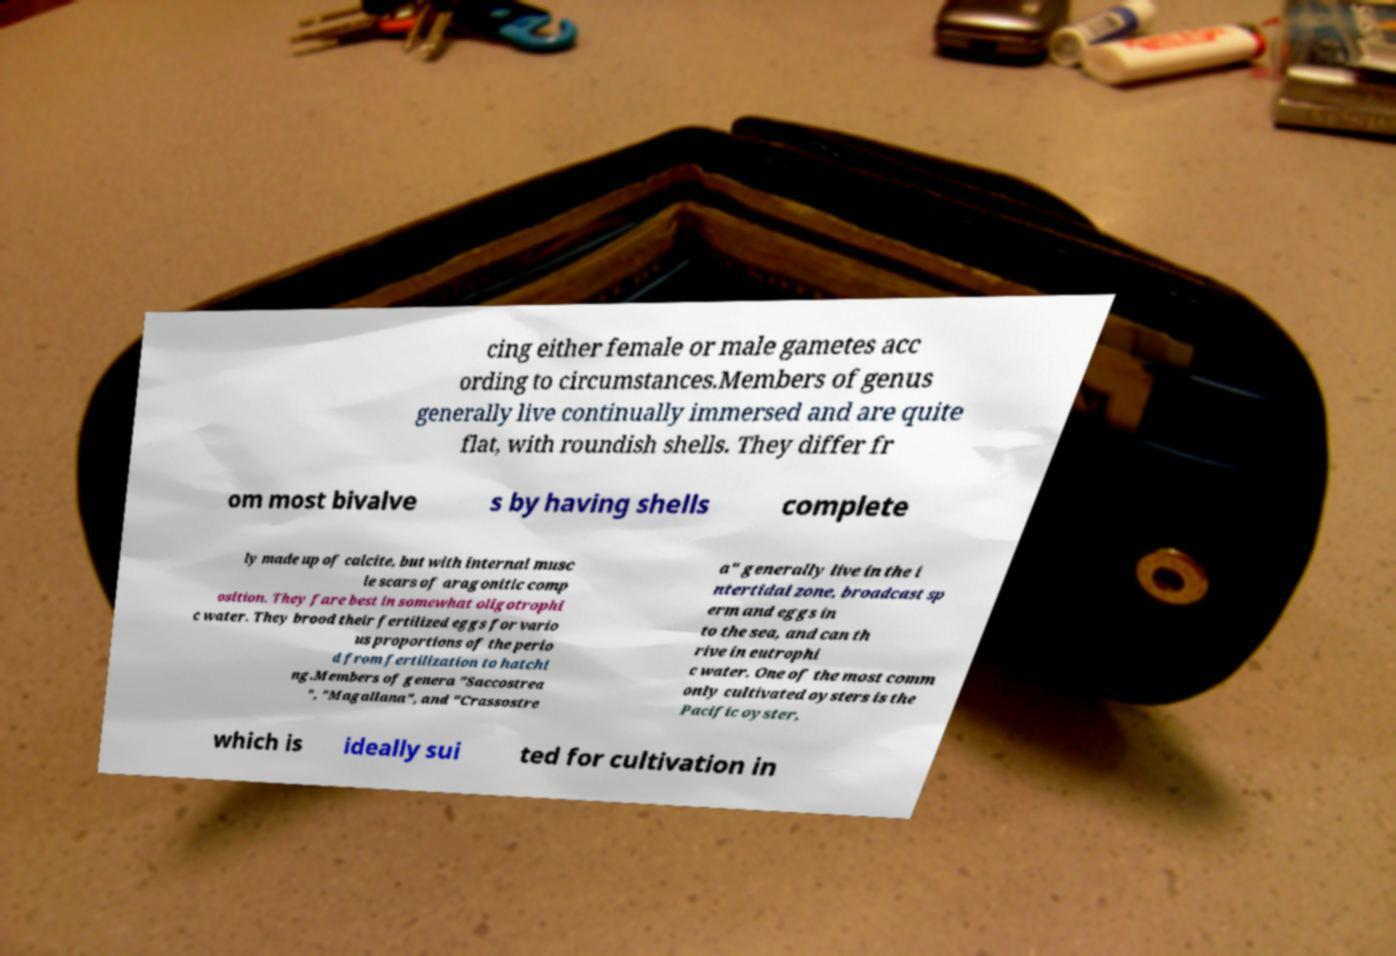Can you accurately transcribe the text from the provided image for me? cing either female or male gametes acc ording to circumstances.Members of genus generally live continually immersed and are quite flat, with roundish shells. They differ fr om most bivalve s by having shells complete ly made up of calcite, but with internal musc le scars of aragonitic comp osition. They fare best in somewhat oligotrophi c water. They brood their fertilized eggs for vario us proportions of the perio d from fertilization to hatchi ng.Members of genera "Saccostrea ", "Magallana", and "Crassostre a" generally live in the i ntertidal zone, broadcast sp erm and eggs in to the sea, and can th rive in eutrophi c water. One of the most comm only cultivated oysters is the Pacific oyster, which is ideally sui ted for cultivation in 